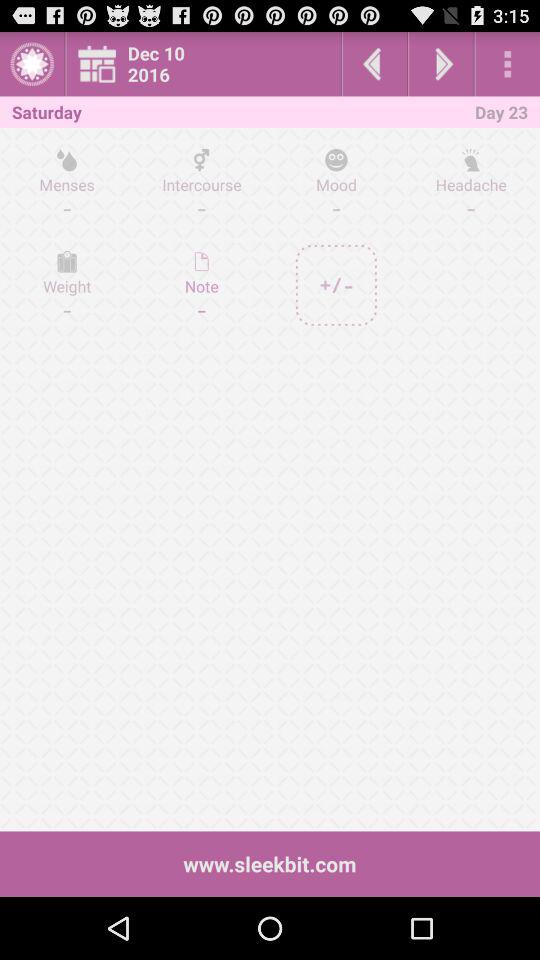What is the website? The website is www.sleekbit.com. 